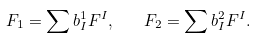Convert formula to latex. <formula><loc_0><loc_0><loc_500><loc_500>F _ { 1 } = \sum b _ { I } ^ { 1 } F ^ { I } , \quad F _ { 2 } = \sum b _ { I } ^ { 2 } F ^ { I } .</formula> 